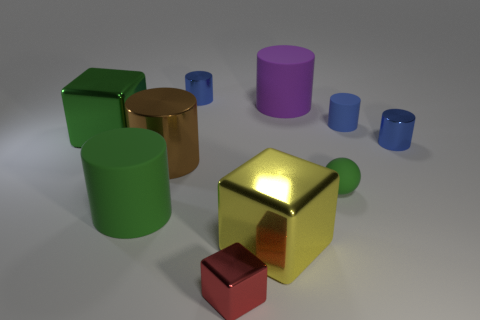Are there any reflections visible on the surfaces of the objects? Yes, there are reflections visible. The shiny metallic surfaces of the objects reflect both the light source and the shadows of the surrounding environment, with the most notable reflections on the large gold-colored cube. 